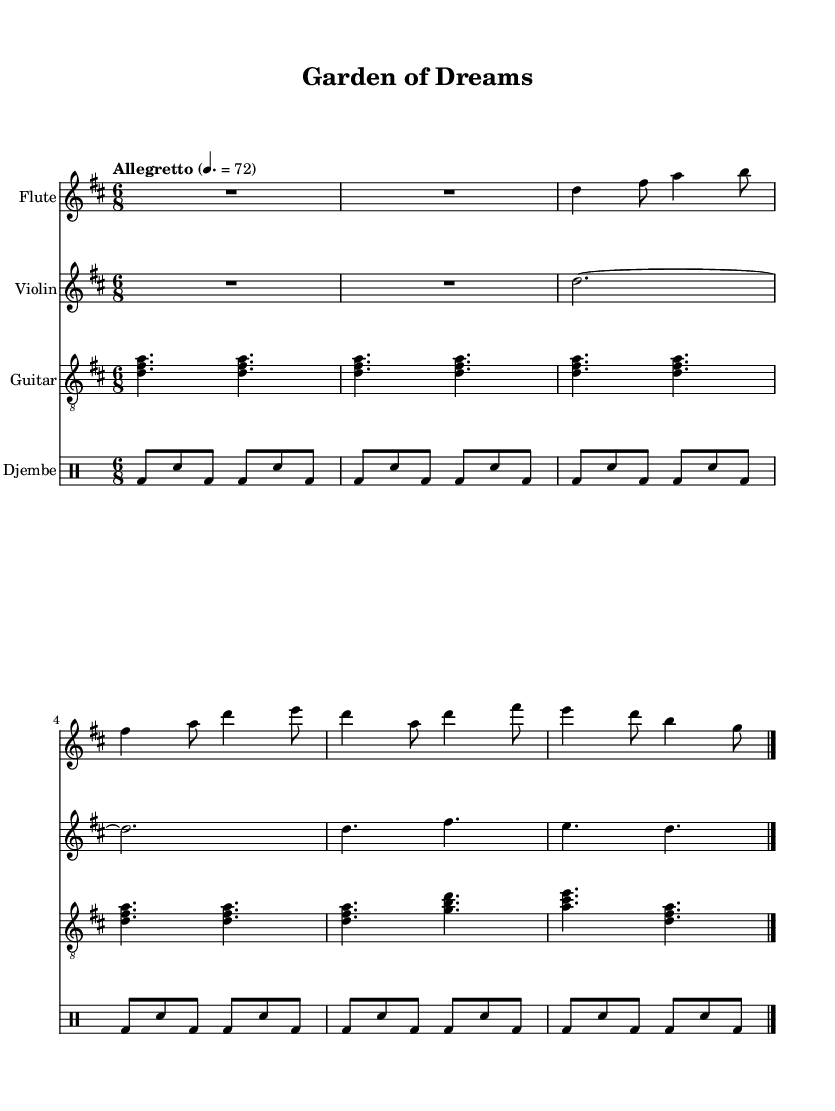What is the key signature of this music? The key signature indicated at the beginning of the score is D major, which has two sharps (F# and C#).
Answer: D major What is the time signature of this music? The time signature shown at the beginning of the score is 6/8, meaning there are six beats per measure, and each beat is an eighth note.
Answer: 6/8 What is the tempo of the piece? The tempo marking states "Allegretto," with a pace of quarter note = 72, which indicates a moderately fast speed for the music.
Answer: Allegretto 4. = 72 How many measures are there for each instrument? Analyzing the score, each instrument, including flute, violin, guitar, and djembe, has 6 measures total displayed in the provided music.
Answer: 6 What is the rhythmic pattern of the djembe? The djembe part alternates between bass and snare hits, suggesting a repeated pattern through measures, contributing to an upbeat and dance-like feel.
Answer: Bass and snare hits How does the guitar part contribute to the fusion style? The guitar features arpeggiated chords striking a balance between folk harmonies and world music, enhancing the eclectic feel while supporting the melody line.
Answer: Arpeggiated chords What role does the flute play in this piece? The flute carries the main melody line, weaving in and out of the harmonic structure, providing a light and airy texture that complements the folk-world fusion.
Answer: Main melody line 